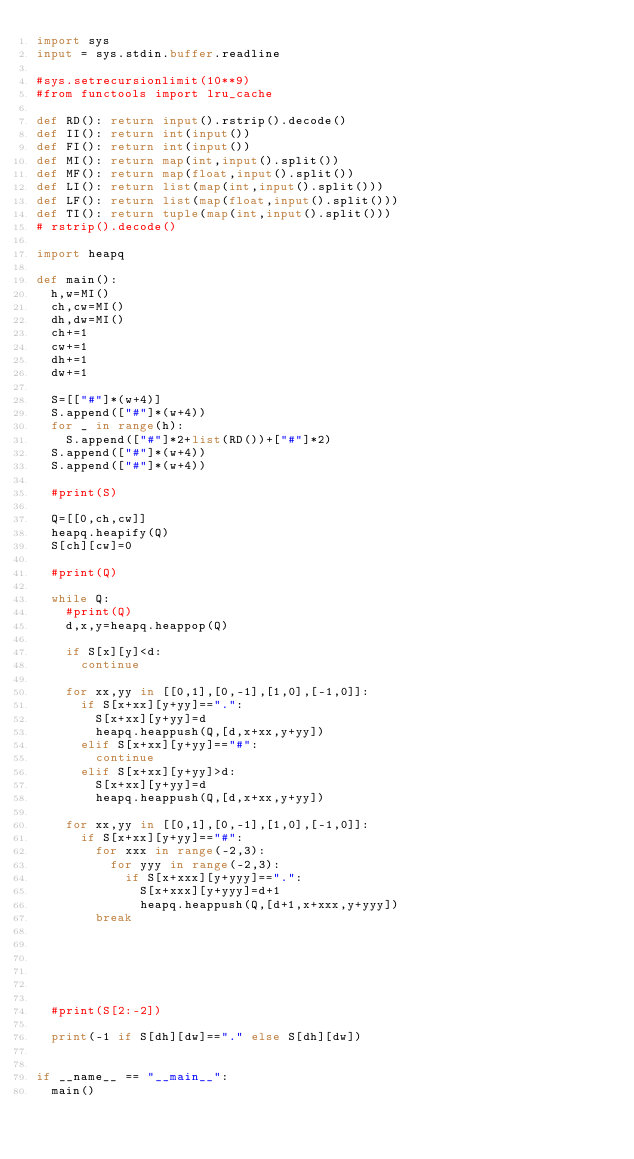Convert code to text. <code><loc_0><loc_0><loc_500><loc_500><_Python_>import sys
input = sys.stdin.buffer.readline

#sys.setrecursionlimit(10**9)
#from functools import lru_cache

def RD(): return input().rstrip().decode()
def II(): return int(input())
def FI(): return int(input())
def MI(): return map(int,input().split())
def MF(): return map(float,input().split())
def LI(): return list(map(int,input().split()))
def LF(): return list(map(float,input().split()))
def TI(): return tuple(map(int,input().split()))
# rstrip().decode()

import heapq

def main():
	h,w=MI()
	ch,cw=MI()
	dh,dw=MI()
	ch+=1
	cw+=1
	dh+=1
	dw+=1

	S=[["#"]*(w+4)]
	S.append(["#"]*(w+4))
	for _ in range(h):
		S.append(["#"]*2+list(RD())+["#"]*2)
	S.append(["#"]*(w+4))
	S.append(["#"]*(w+4))

	#print(S)

	Q=[[0,ch,cw]]
	heapq.heapify(Q)
	S[ch][cw]=0

	#print(Q)

	while Q:
		#print(Q)
		d,x,y=heapq.heappop(Q)

		if S[x][y]<d:
			continue

		for xx,yy in [[0,1],[0,-1],[1,0],[-1,0]]:
			if S[x+xx][y+yy]==".":
				S[x+xx][y+yy]=d
				heapq.heappush(Q,[d,x+xx,y+yy])
			elif S[x+xx][y+yy]=="#":
				continue
			elif S[x+xx][y+yy]>d:
				S[x+xx][y+yy]=d
				heapq.heappush(Q,[d,x+xx,y+yy])

		for xx,yy in [[0,1],[0,-1],[1,0],[-1,0]]:
			if S[x+xx][y+yy]=="#":
				for xxx in range(-2,3):
					for yyy in range(-2,3):
						if S[x+xxx][y+yyy]==".":
							S[x+xxx][y+yyy]=d+1
							heapq.heappush(Q,[d+1,x+xxx,y+yyy])
				break






	#print(S[2:-2])

	print(-1 if S[dh][dw]=="." else S[dh][dw])


if __name__ == "__main__":
	main()
</code> 